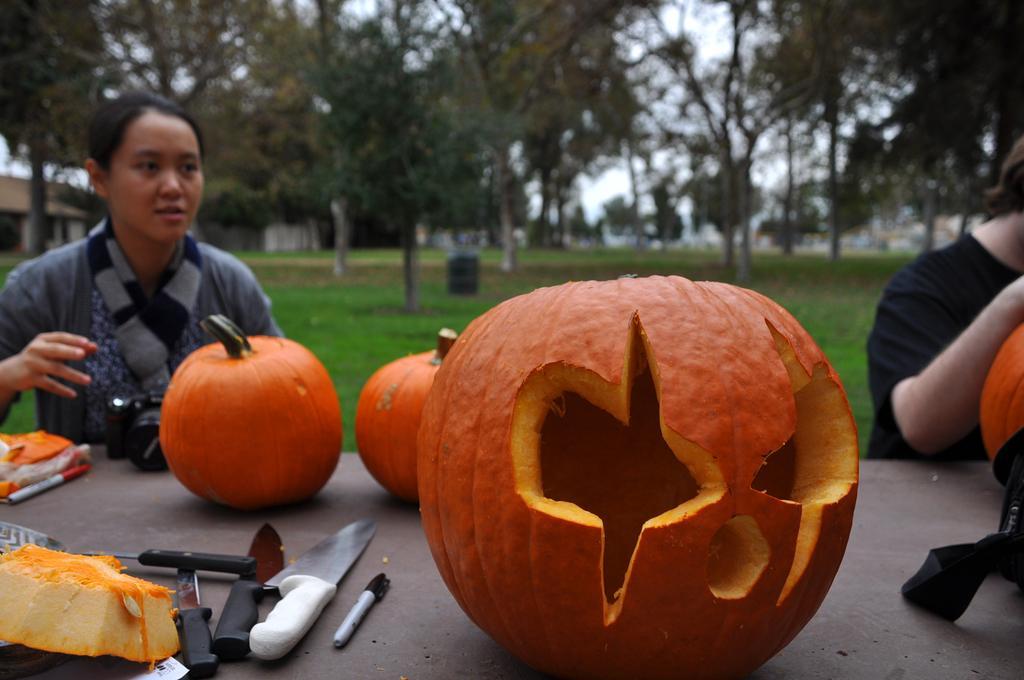How would you summarize this image in a sentence or two? In the foreground of this image, on the table, there are pumpkins and a pumpkin carved, few knives, marker, a piece of pumpkin, camera and a bag are on it. In the background, there are two persons sitting near the table, grass, trees, an object on the grass and the sky on the top. 